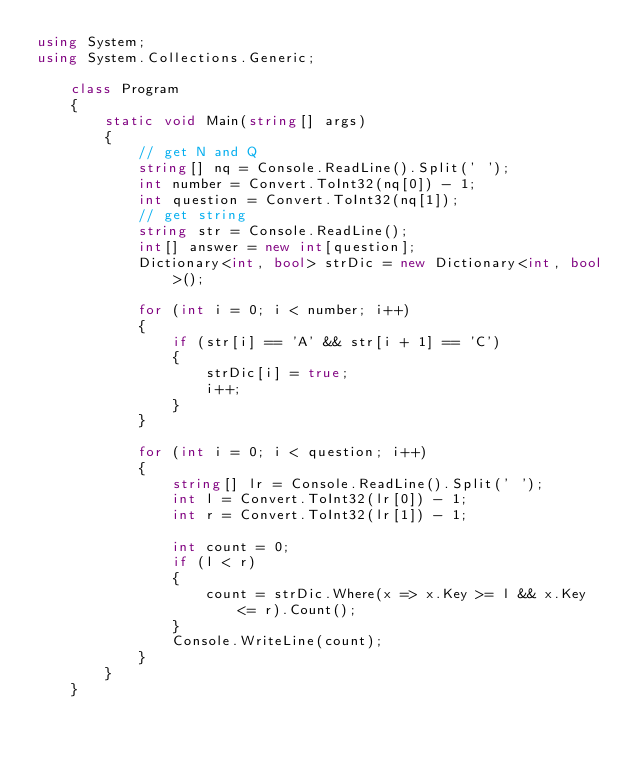<code> <loc_0><loc_0><loc_500><loc_500><_C#_>using System;
using System.Collections.Generic;

    class Program
    {
        static void Main(string[] args)
        {
            // get N and Q
            string[] nq = Console.ReadLine().Split(' ');
            int number = Convert.ToInt32(nq[0]) - 1;
            int question = Convert.ToInt32(nq[1]);
            // get string
            string str = Console.ReadLine();
            int[] answer = new int[question];
            Dictionary<int, bool> strDic = new Dictionary<int, bool>();

            for (int i = 0; i < number; i++)
            {
                if (str[i] == 'A' && str[i + 1] == 'C')
                {
                    strDic[i] = true;
                    i++;
                }
            }

            for (int i = 0; i < question; i++)
            {
                string[] lr = Console.ReadLine().Split(' ');
                int l = Convert.ToInt32(lr[0]) - 1;
                int r = Convert.ToInt32(lr[1]) - 1;

                int count = 0;
                if (l < r)
                {
                    count = strDic.Where(x => x.Key >= l && x.Key <= r).Count();
                }
                Console.WriteLine(count);
            }
        }
    }</code> 